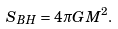Convert formula to latex. <formula><loc_0><loc_0><loc_500><loc_500>S _ { B H } = 4 \pi G M ^ { 2 } .</formula> 